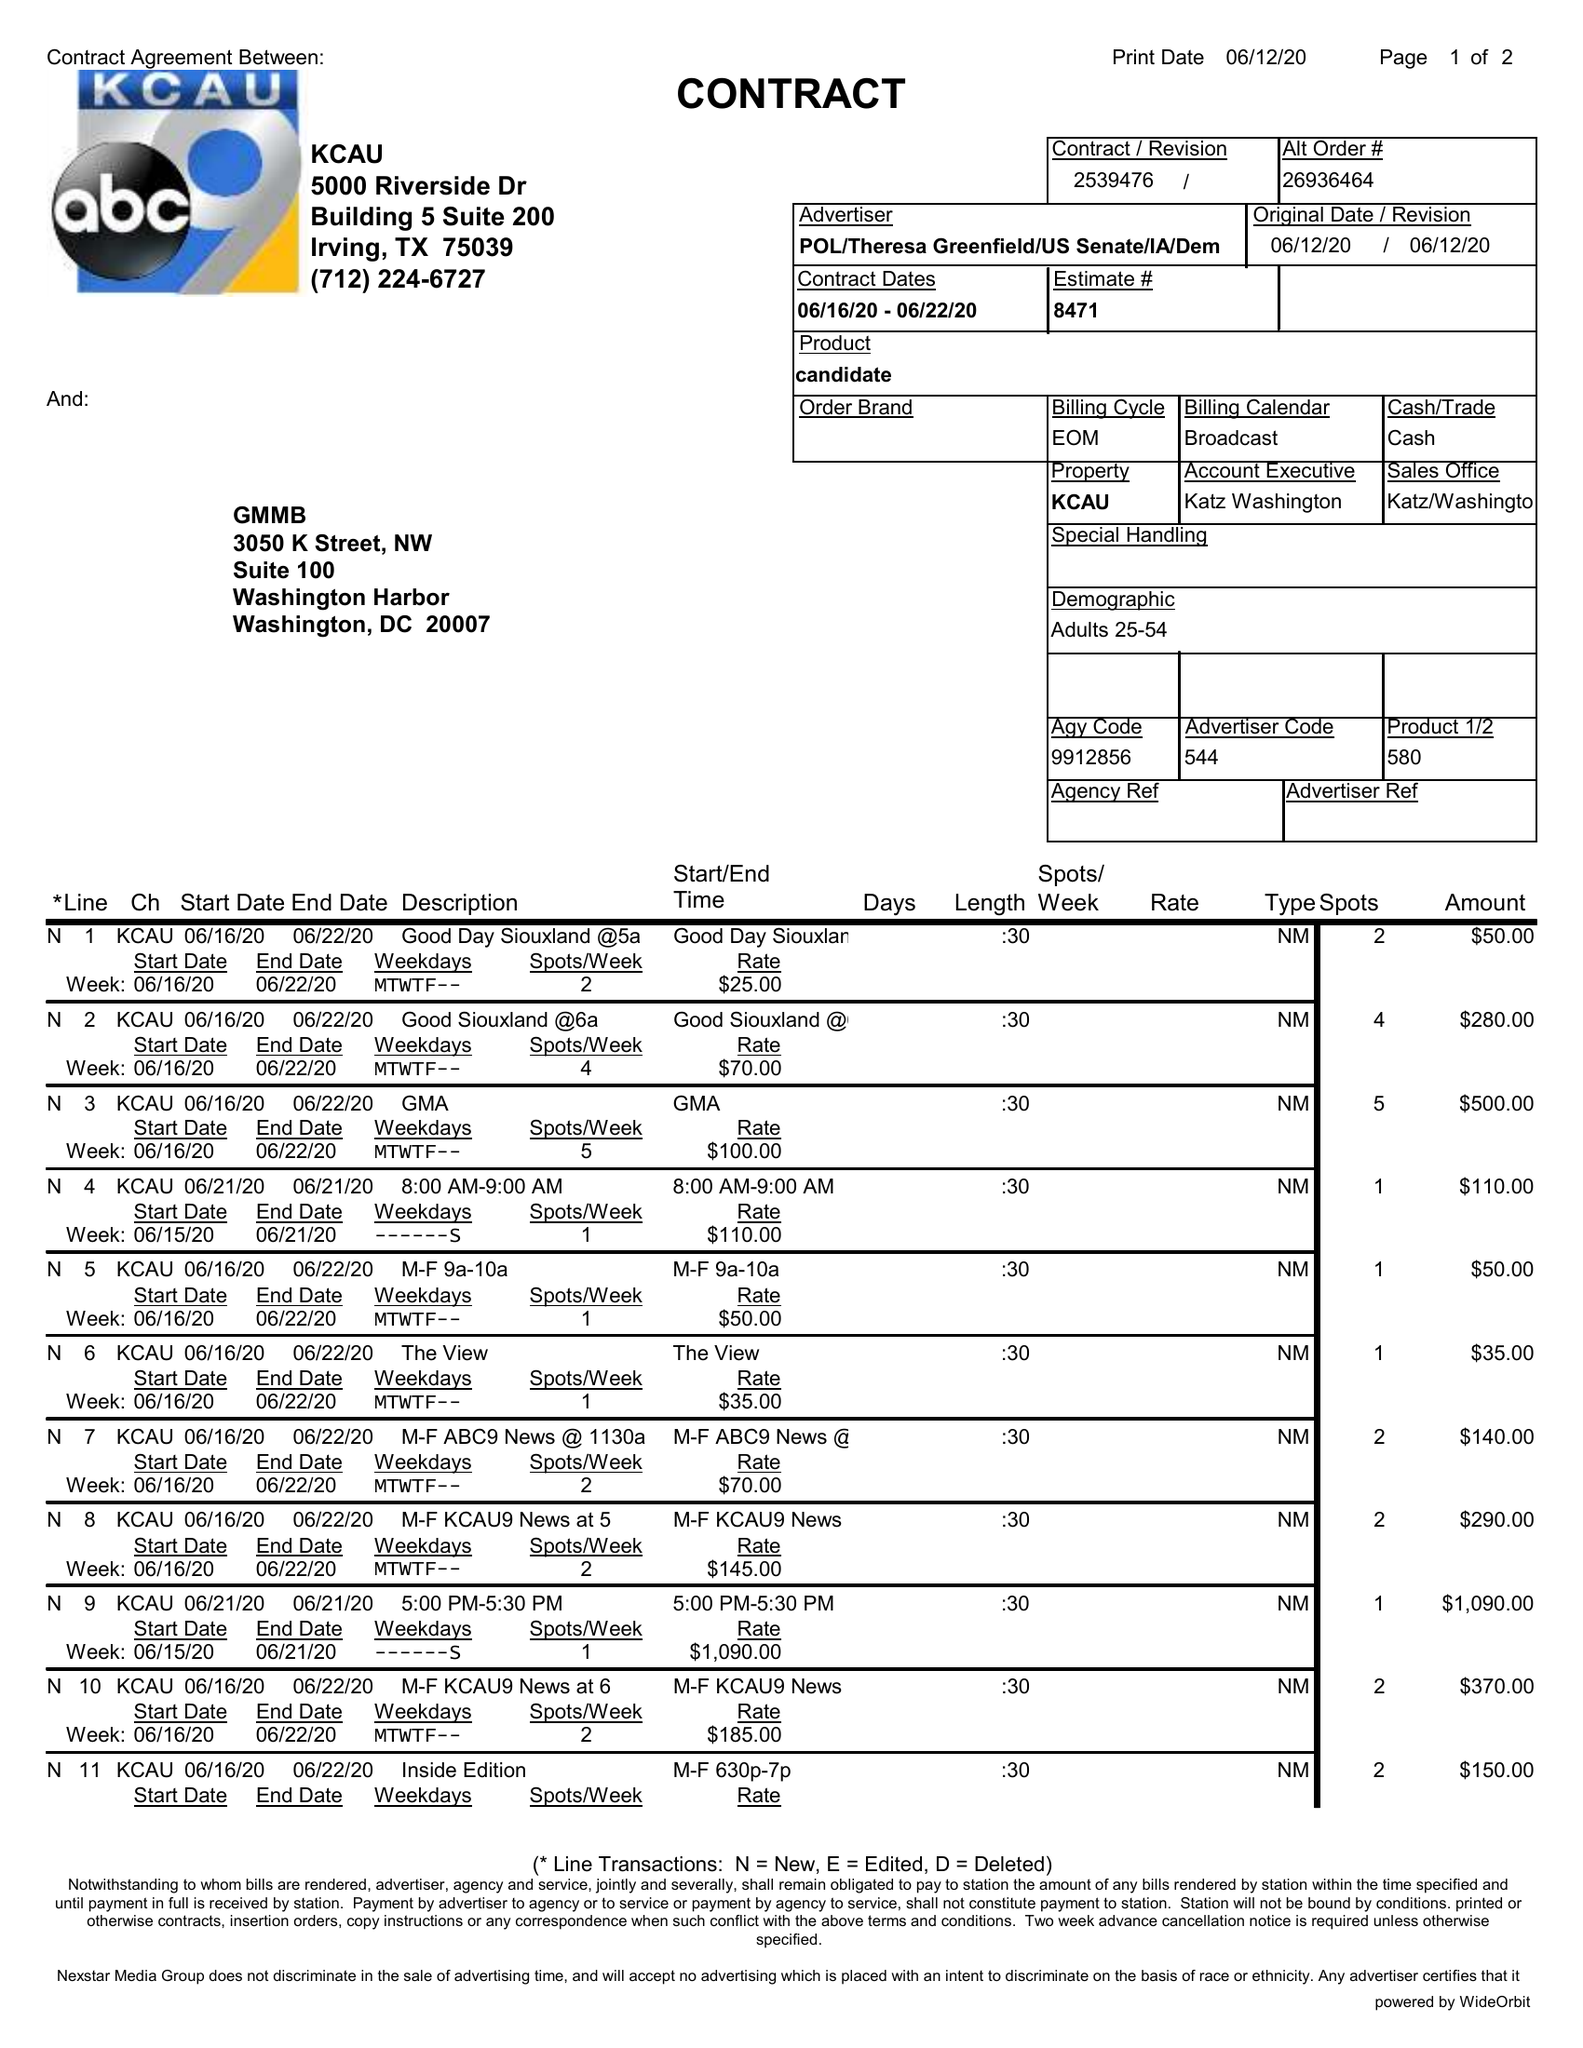What is the value for the flight_to?
Answer the question using a single word or phrase. 06/22/20 